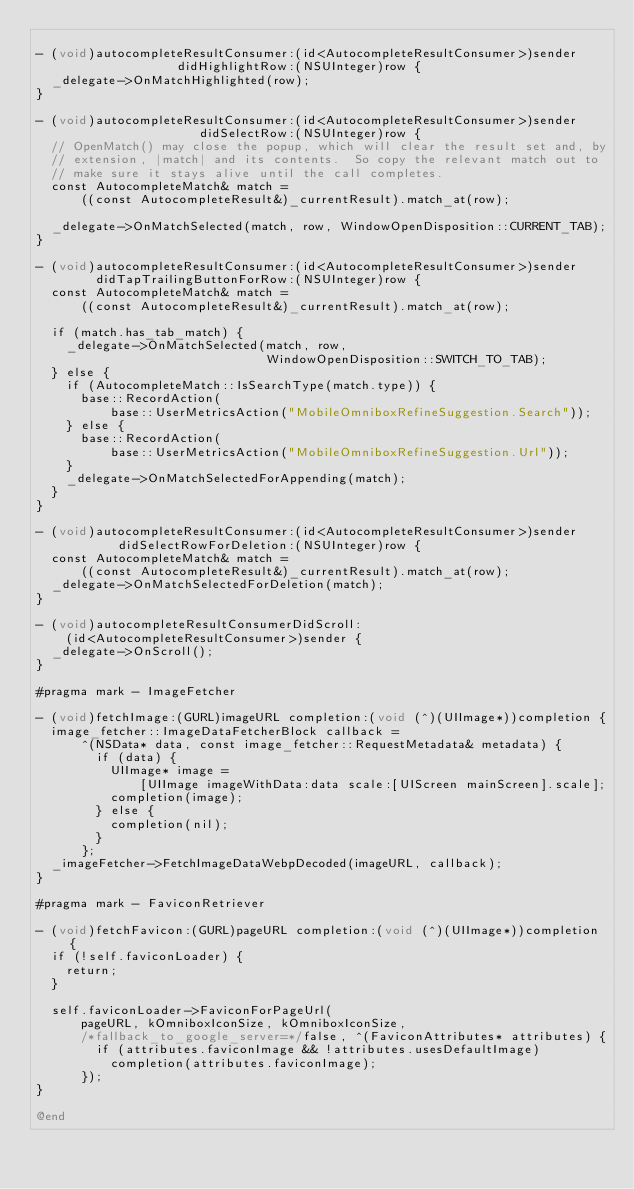<code> <loc_0><loc_0><loc_500><loc_500><_ObjectiveC_>
- (void)autocompleteResultConsumer:(id<AutocompleteResultConsumer>)sender
                   didHighlightRow:(NSUInteger)row {
  _delegate->OnMatchHighlighted(row);
}

- (void)autocompleteResultConsumer:(id<AutocompleteResultConsumer>)sender
                      didSelectRow:(NSUInteger)row {
  // OpenMatch() may close the popup, which will clear the result set and, by
  // extension, |match| and its contents.  So copy the relevant match out to
  // make sure it stays alive until the call completes.
  const AutocompleteMatch& match =
      ((const AutocompleteResult&)_currentResult).match_at(row);

  _delegate->OnMatchSelected(match, row, WindowOpenDisposition::CURRENT_TAB);
}

- (void)autocompleteResultConsumer:(id<AutocompleteResultConsumer>)sender
        didTapTrailingButtonForRow:(NSUInteger)row {
  const AutocompleteMatch& match =
      ((const AutocompleteResult&)_currentResult).match_at(row);

  if (match.has_tab_match) {
    _delegate->OnMatchSelected(match, row,
                               WindowOpenDisposition::SWITCH_TO_TAB);
  } else {
    if (AutocompleteMatch::IsSearchType(match.type)) {
      base::RecordAction(
          base::UserMetricsAction("MobileOmniboxRefineSuggestion.Search"));
    } else {
      base::RecordAction(
          base::UserMetricsAction("MobileOmniboxRefineSuggestion.Url"));
    }
    _delegate->OnMatchSelectedForAppending(match);
  }
}

- (void)autocompleteResultConsumer:(id<AutocompleteResultConsumer>)sender
           didSelectRowForDeletion:(NSUInteger)row {
  const AutocompleteMatch& match =
      ((const AutocompleteResult&)_currentResult).match_at(row);
  _delegate->OnMatchSelectedForDeletion(match);
}

- (void)autocompleteResultConsumerDidScroll:
    (id<AutocompleteResultConsumer>)sender {
  _delegate->OnScroll();
}

#pragma mark - ImageFetcher

- (void)fetchImage:(GURL)imageURL completion:(void (^)(UIImage*))completion {
  image_fetcher::ImageDataFetcherBlock callback =
      ^(NSData* data, const image_fetcher::RequestMetadata& metadata) {
        if (data) {
          UIImage* image =
              [UIImage imageWithData:data scale:[UIScreen mainScreen].scale];
          completion(image);
        } else {
          completion(nil);
        }
      };
  _imageFetcher->FetchImageDataWebpDecoded(imageURL, callback);
}

#pragma mark - FaviconRetriever

- (void)fetchFavicon:(GURL)pageURL completion:(void (^)(UIImage*))completion {
  if (!self.faviconLoader) {
    return;
  }

  self.faviconLoader->FaviconForPageUrl(
      pageURL, kOmniboxIconSize, kOmniboxIconSize,
      /*fallback_to_google_server=*/false, ^(FaviconAttributes* attributes) {
        if (attributes.faviconImage && !attributes.usesDefaultImage)
          completion(attributes.faviconImage);
      });
}

@end
</code> 